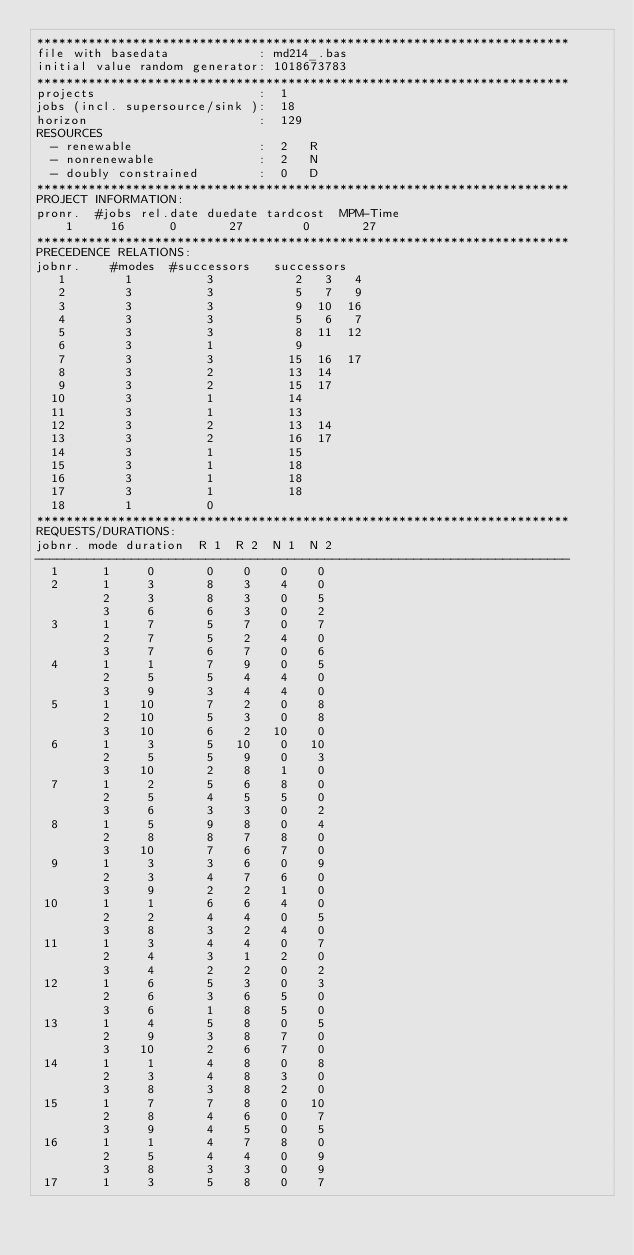Convert code to text. <code><loc_0><loc_0><loc_500><loc_500><_ObjectiveC_>************************************************************************
file with basedata            : md214_.bas
initial value random generator: 1018673783
************************************************************************
projects                      :  1
jobs (incl. supersource/sink ):  18
horizon                       :  129
RESOURCES
  - renewable                 :  2   R
  - nonrenewable              :  2   N
  - doubly constrained        :  0   D
************************************************************************
PROJECT INFORMATION:
pronr.  #jobs rel.date duedate tardcost  MPM-Time
    1     16      0       27        0       27
************************************************************************
PRECEDENCE RELATIONS:
jobnr.    #modes  #successors   successors
   1        1          3           2   3   4
   2        3          3           5   7   9
   3        3          3           9  10  16
   4        3          3           5   6   7
   5        3          3           8  11  12
   6        3          1           9
   7        3          3          15  16  17
   8        3          2          13  14
   9        3          2          15  17
  10        3          1          14
  11        3          1          13
  12        3          2          13  14
  13        3          2          16  17
  14        3          1          15
  15        3          1          18
  16        3          1          18
  17        3          1          18
  18        1          0        
************************************************************************
REQUESTS/DURATIONS:
jobnr. mode duration  R 1  R 2  N 1  N 2
------------------------------------------------------------------------
  1      1     0       0    0    0    0
  2      1     3       8    3    4    0
         2     3       8    3    0    5
         3     6       6    3    0    2
  3      1     7       5    7    0    7
         2     7       5    2    4    0
         3     7       6    7    0    6
  4      1     1       7    9    0    5
         2     5       5    4    4    0
         3     9       3    4    4    0
  5      1    10       7    2    0    8
         2    10       5    3    0    8
         3    10       6    2   10    0
  6      1     3       5   10    0   10
         2     5       5    9    0    3
         3    10       2    8    1    0
  7      1     2       5    6    8    0
         2     5       4    5    5    0
         3     6       3    3    0    2
  8      1     5       9    8    0    4
         2     8       8    7    8    0
         3    10       7    6    7    0
  9      1     3       3    6    0    9
         2     3       4    7    6    0
         3     9       2    2    1    0
 10      1     1       6    6    4    0
         2     2       4    4    0    5
         3     8       3    2    4    0
 11      1     3       4    4    0    7
         2     4       3    1    2    0
         3     4       2    2    0    2
 12      1     6       5    3    0    3
         2     6       3    6    5    0
         3     6       1    8    5    0
 13      1     4       5    8    0    5
         2     9       3    8    7    0
         3    10       2    6    7    0
 14      1     1       4    8    0    8
         2     3       4    8    3    0
         3     8       3    8    2    0
 15      1     7       7    8    0   10
         2     8       4    6    0    7
         3     9       4    5    0    5
 16      1     1       4    7    8    0
         2     5       4    4    0    9
         3     8       3    3    0    9
 17      1     3       5    8    0    7</code> 